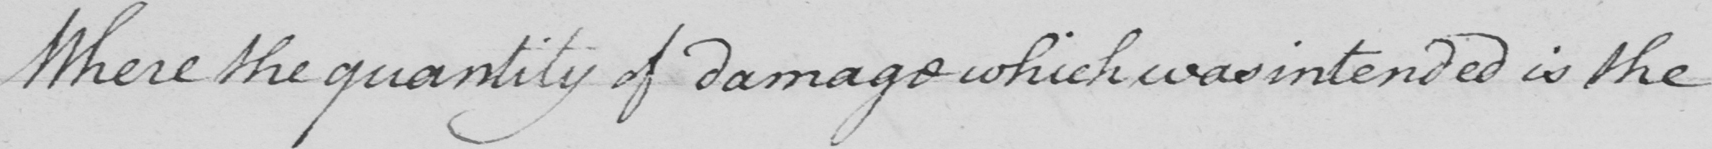Can you tell me what this handwritten text says? Where the quantity of damage which was intended is the 